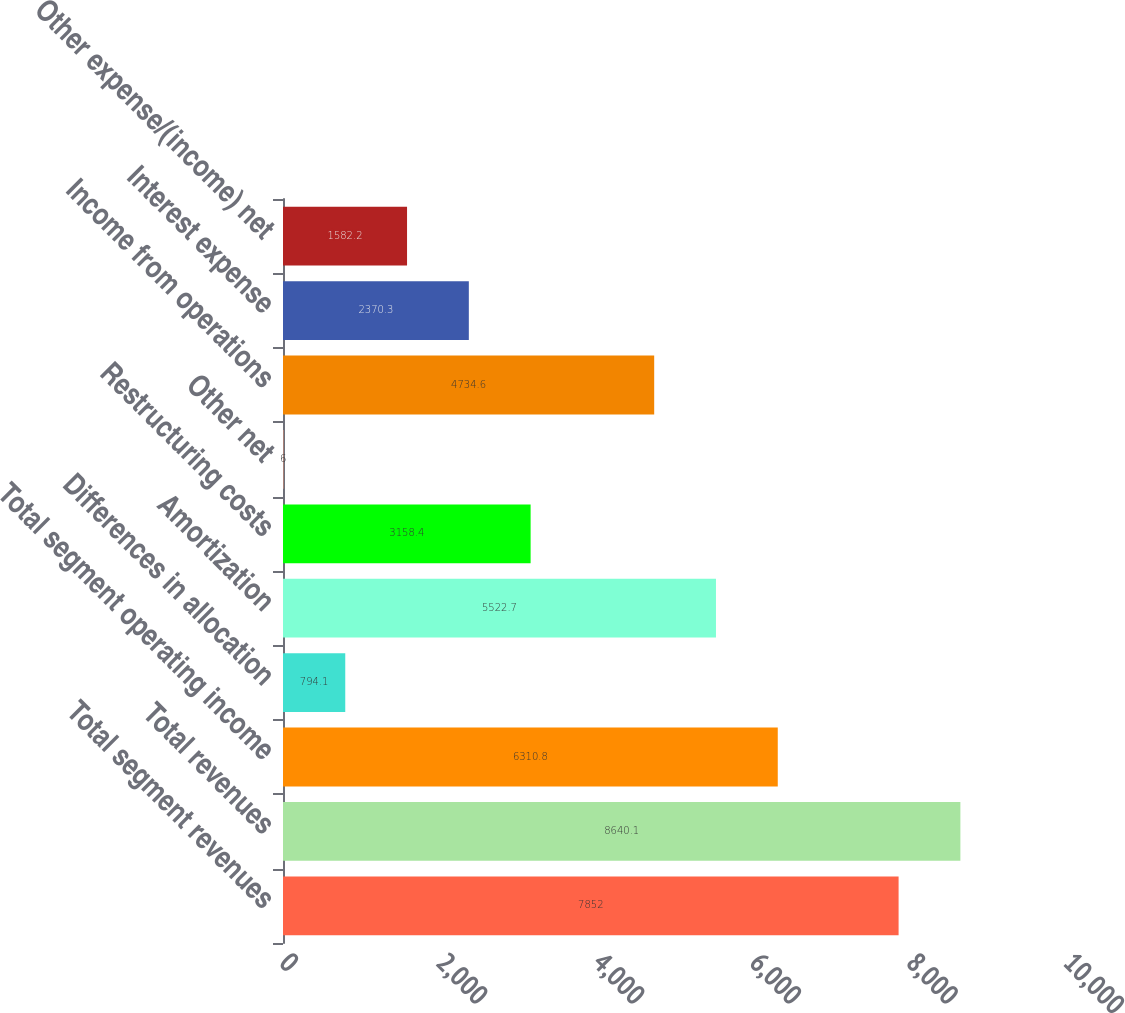Convert chart to OTSL. <chart><loc_0><loc_0><loc_500><loc_500><bar_chart><fcel>Total segment revenues<fcel>Total revenues<fcel>Total segment operating income<fcel>Differences in allocation<fcel>Amortization<fcel>Restructuring costs<fcel>Other net<fcel>Income from operations<fcel>Interest expense<fcel>Other expense/(income) net<nl><fcel>7852<fcel>8640.1<fcel>6310.8<fcel>794.1<fcel>5522.7<fcel>3158.4<fcel>6<fcel>4734.6<fcel>2370.3<fcel>1582.2<nl></chart> 